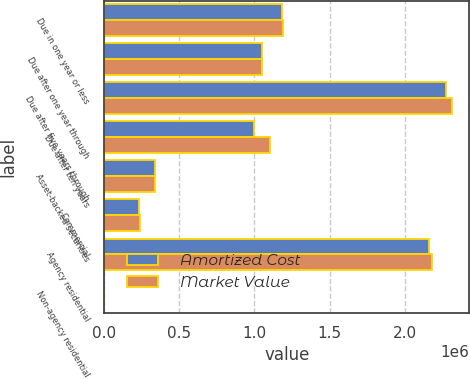Convert chart. <chart><loc_0><loc_0><loc_500><loc_500><stacked_bar_chart><ecel><fcel>Due in one year or less<fcel>Due after one year through<fcel>Due after five years through<fcel>Due after ten years<fcel>Asset-backed securities<fcel>Commercial<fcel>Agency residential<fcel>Non-agency residential<nl><fcel>Amortized Cost<fcel>1.18325e+06<fcel>1.05108e+06<fcel>2.27007e+06<fcel>999257<fcel>340761<fcel>231439<fcel>2.15718e+06<fcel>2734<nl><fcel>Market Value<fcel>1.18942e+06<fcel>1.05108e+06<fcel>2.31367e+06<fcel>1.1029e+06<fcel>341222<fcel>241685<fcel>2.18316e+06<fcel>2731<nl></chart> 